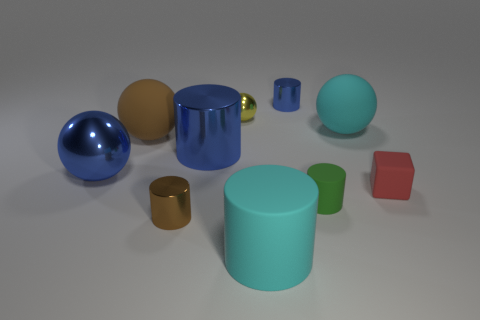There is a large ball that is the same color as the large shiny cylinder; what material is it?
Keep it short and to the point. Metal. How many tiny objects are either green matte things or cyan matte spheres?
Make the answer very short. 1. The cube is what color?
Offer a very short reply. Red. There is a metal sphere on the left side of the yellow sphere; are there any blue things in front of it?
Ensure brevity in your answer.  No. Is the number of big things right of the tiny brown shiny cylinder less than the number of cyan cylinders?
Offer a very short reply. No. Is the material of the brown object in front of the red rubber thing the same as the cyan cylinder?
Keep it short and to the point. No. What color is the tiny cylinder that is made of the same material as the small red block?
Your response must be concise. Green. Is the number of green matte cylinders in front of the small red cube less than the number of tiny blue things to the left of the cyan cylinder?
Offer a terse response. No. Is the color of the tiny shiny cylinder that is to the right of the big cyan cylinder the same as the shiny thing in front of the blue metal ball?
Provide a succinct answer. No. Are there any blue blocks made of the same material as the yellow sphere?
Your response must be concise. No. 